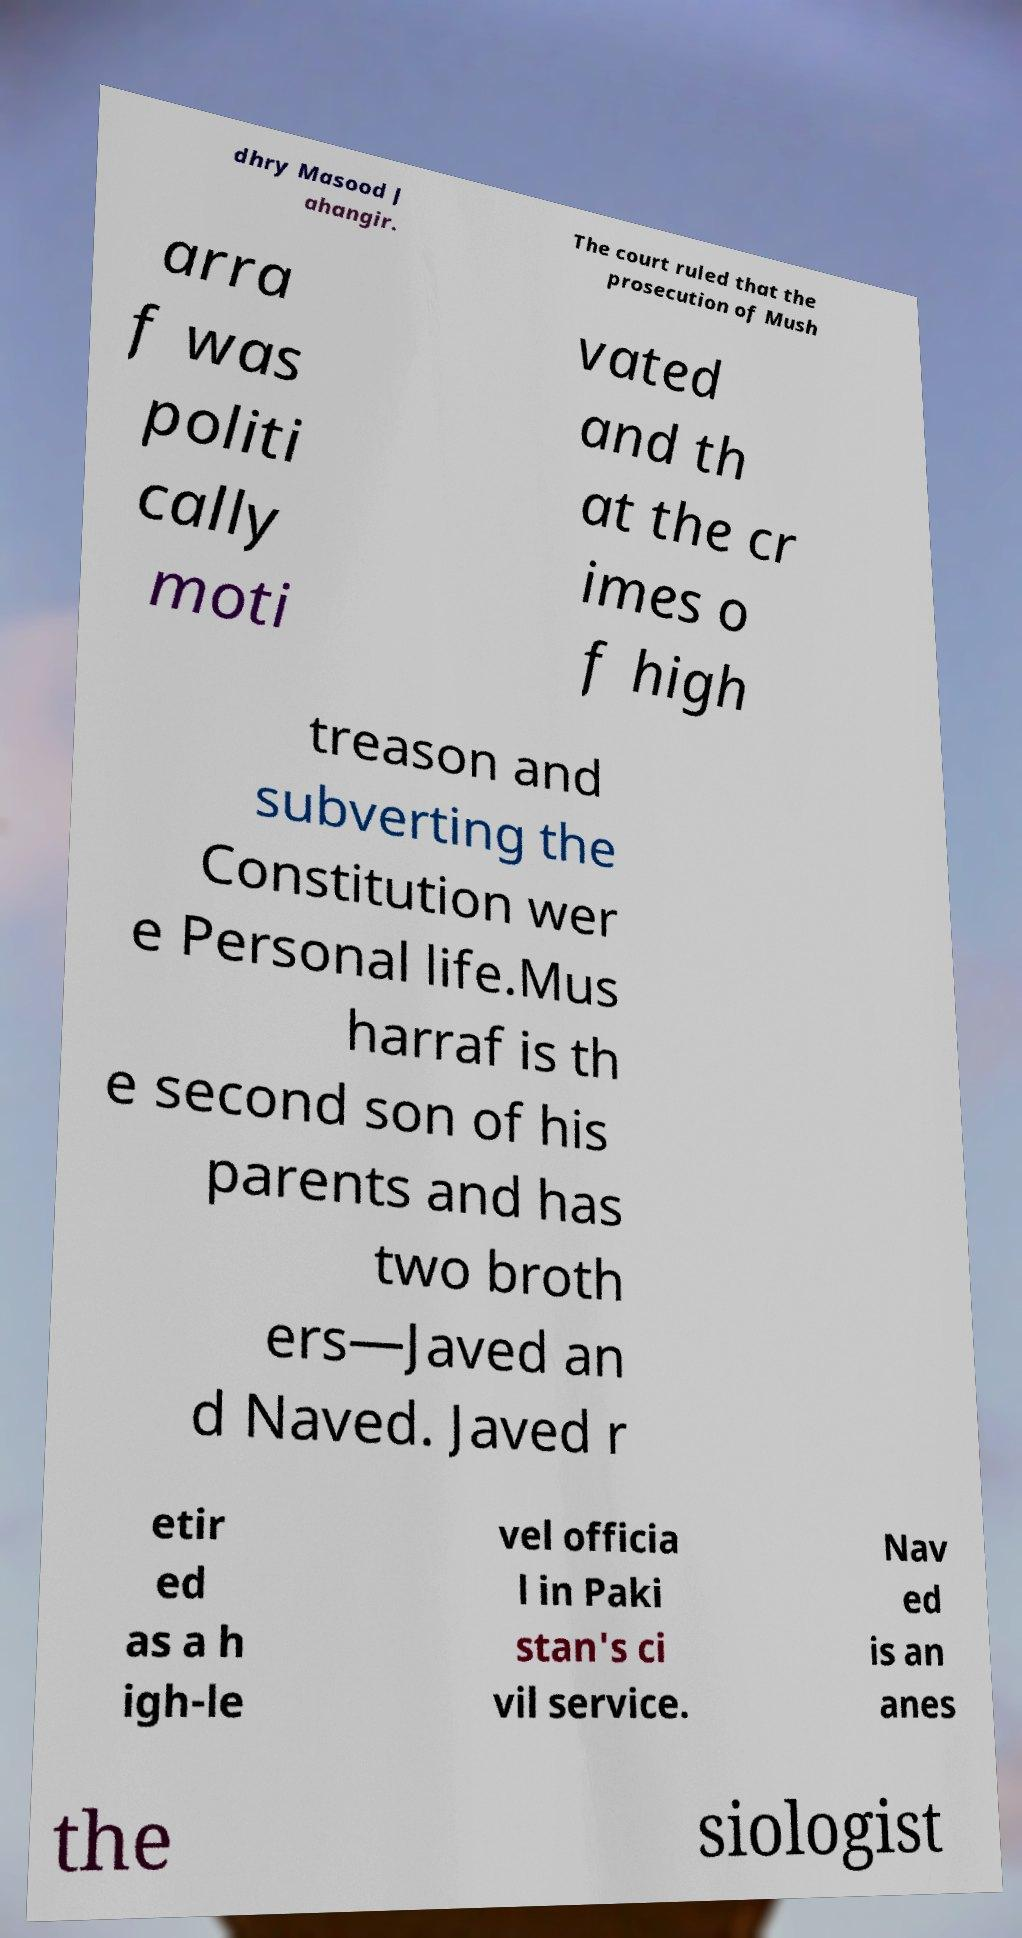There's text embedded in this image that I need extracted. Can you transcribe it verbatim? dhry Masood J ahangir. The court ruled that the prosecution of Mush arra f was politi cally moti vated and th at the cr imes o f high treason and subverting the Constitution wer e Personal life.Mus harraf is th e second son of his parents and has two broth ers—Javed an d Naved. Javed r etir ed as a h igh-le vel officia l in Paki stan's ci vil service. Nav ed is an anes the siologist 